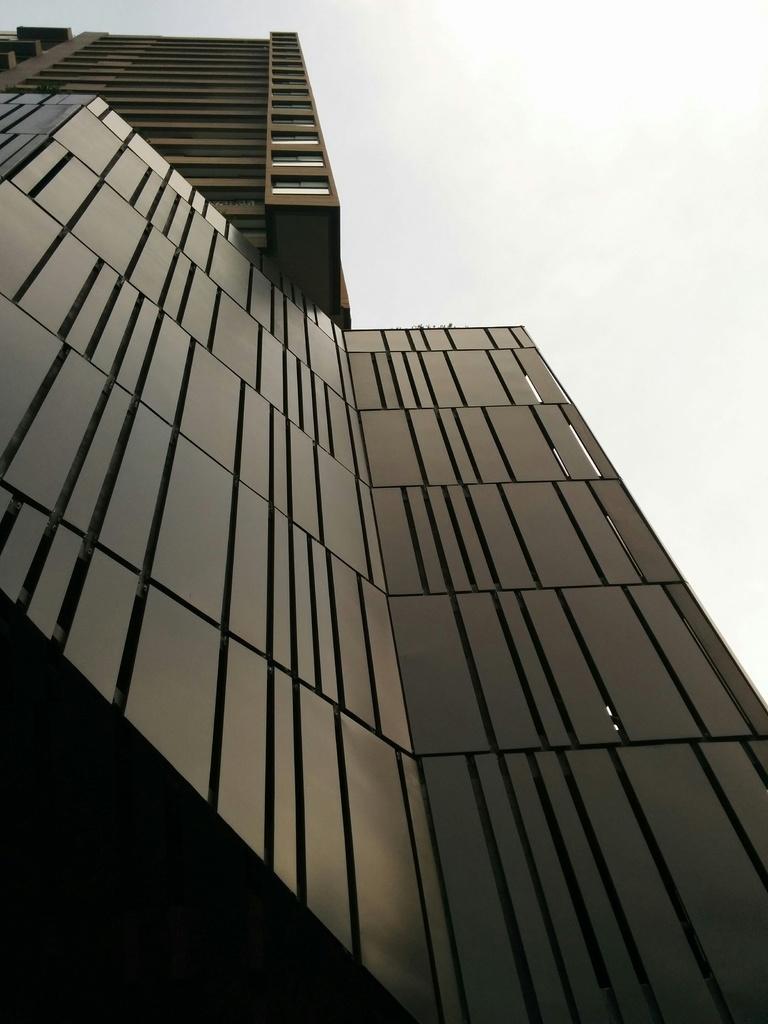In one or two sentences, can you explain what this image depicts? In this image in front there is a building. In the background of the image there is sky. 